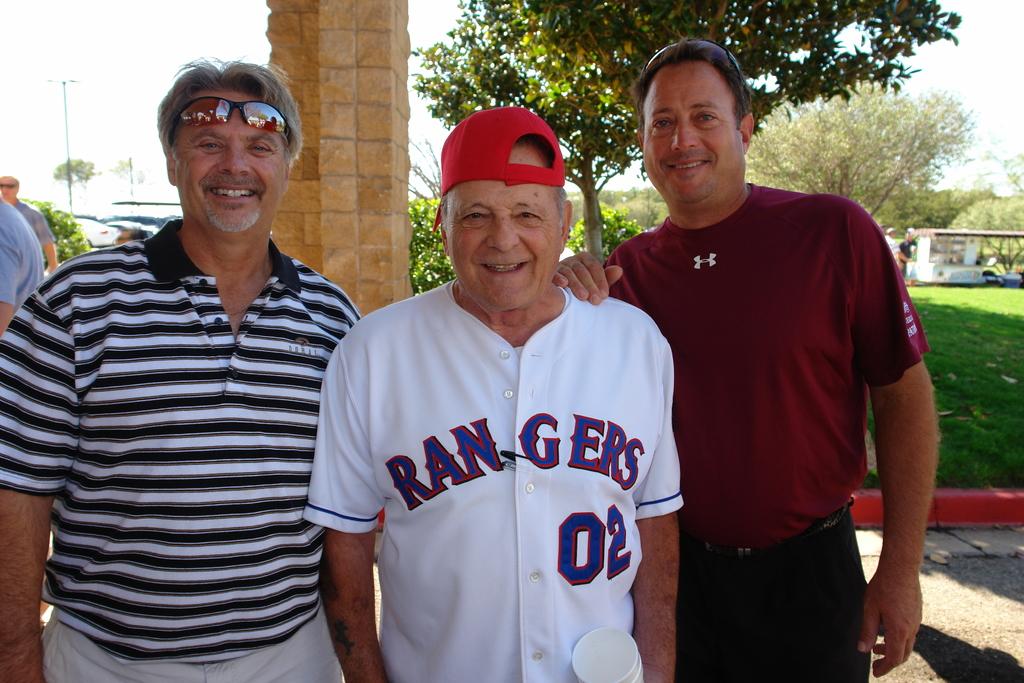What sports team is on the jersey of the man in the red cap?
Your answer should be very brief. Rangers. What is the player's number?
Your answer should be compact. 02. 